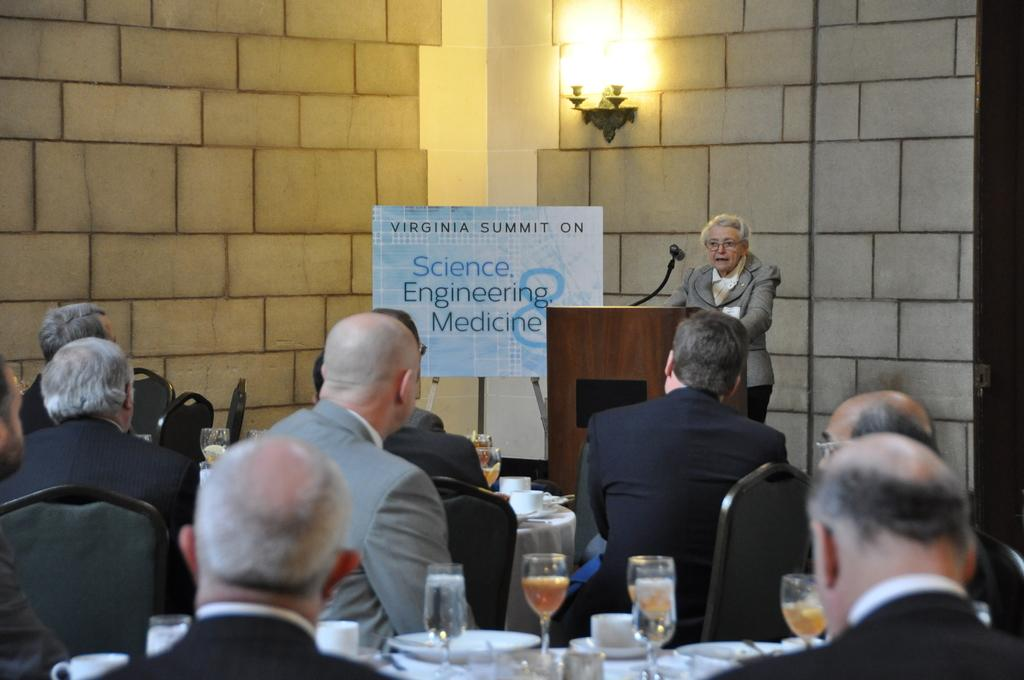What is happening in the image involving a group of people? There is a group of people sitting on chairs in the image. Who is speaking to the group of people? A lady is addressing the group of people. What else can be seen in the image besides the group of people? Drinks are present on a table in the image. What type of produce is being displayed on the wall in the image? There is no produce displayed on the wall in the image; it only shows a group of people sitting on chairs, a lady addressing them, and drinks on a table. 